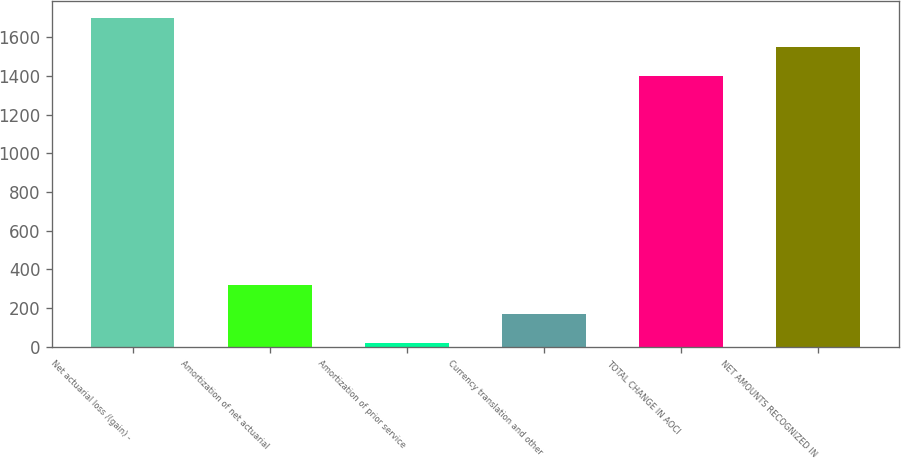<chart> <loc_0><loc_0><loc_500><loc_500><bar_chart><fcel>Net actuarial loss /(gain) -<fcel>Amortization of net actuarial<fcel>Amortization of prior service<fcel>Currency translation and other<fcel>TOTAL CHANGE IN AOCI<fcel>NET AMOUNTS RECOGNIZED IN<nl><fcel>1700.2<fcel>319.2<fcel>20<fcel>169.6<fcel>1401<fcel>1550.6<nl></chart> 